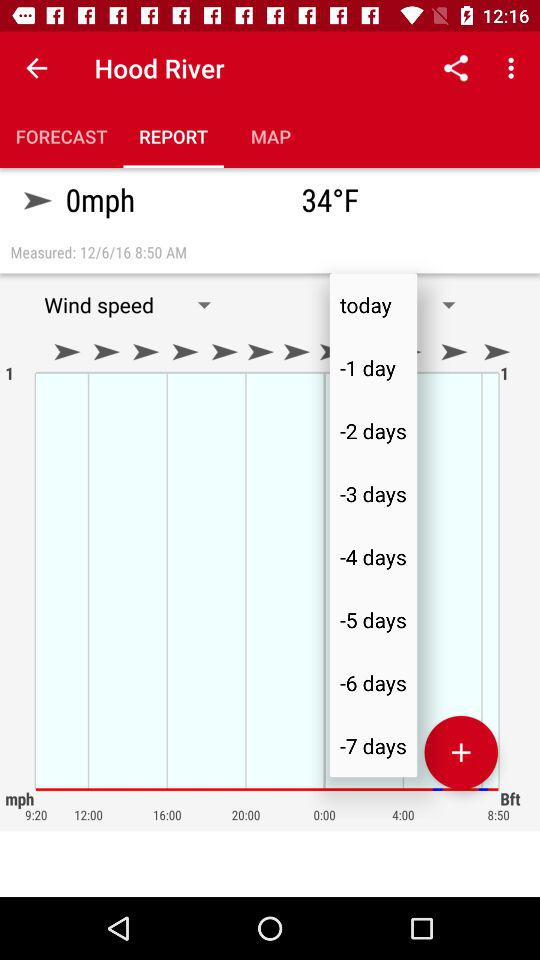What is the time of the report? The time of the report is 8:50 AM. 